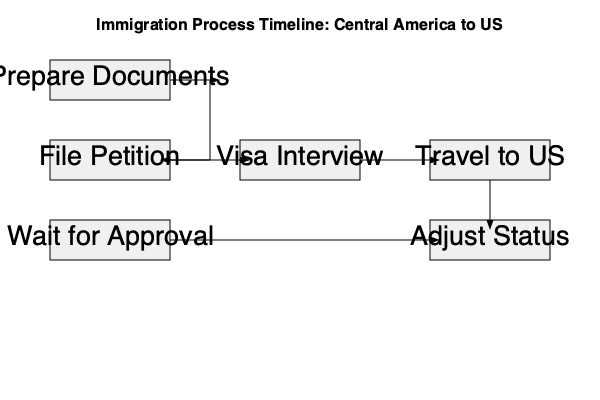Based on the flowchart of the immigration process from Central America to the US, which step directly follows the "Visa Interview" stage? To answer this question, we need to carefully examine the flowchart and follow the process step-by-step:

1. The immigration process begins with "Prepare Documents."
2. This is followed by "File Petition."
3. After filing the petition, there's a "Wait for Approval" stage.
4. Once approved, the next step is the "Visa Interview."
5. After the "Visa Interview," we can see an arrow pointing directly to the "Travel to US" box.
6. The final step shown is "Adjust Status."

By following the arrows in the flowchart, we can clearly see that the step immediately after the "Visa Interview" is "Travel to US." This makes logical sense in the immigration process, as once an individual has successfully completed their visa interview and been approved, they would then be allowed to travel to the United States.
Answer: Travel to US 